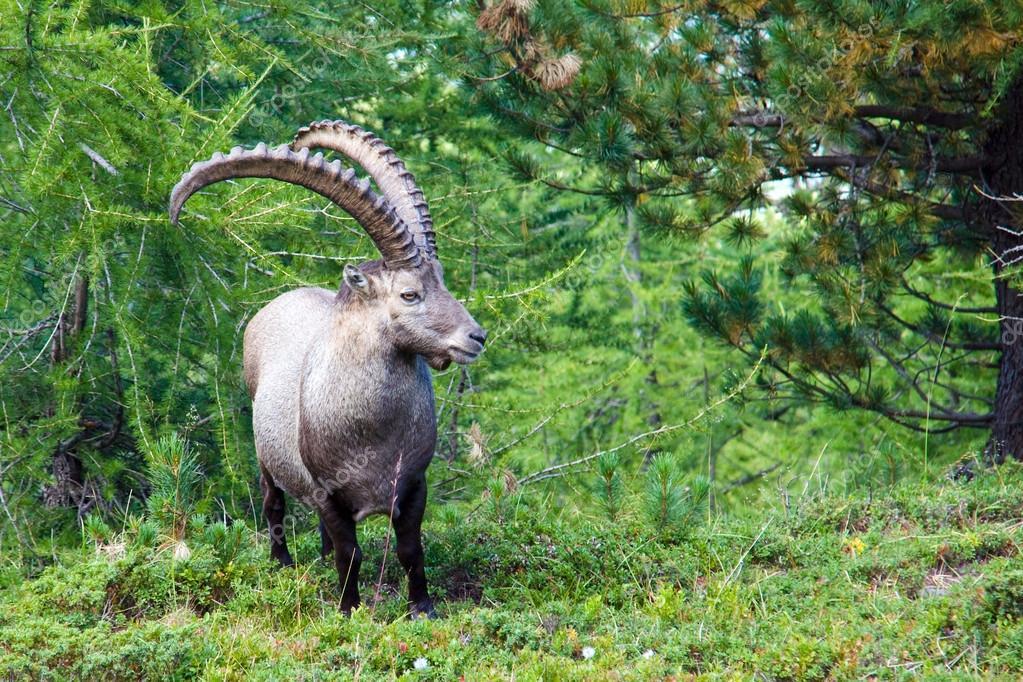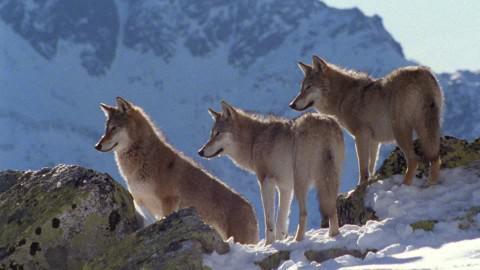The first image is the image on the left, the second image is the image on the right. Given the left and right images, does the statement "the sky is visible in the image on the right" hold true? Answer yes or no. Yes. The first image is the image on the left, the second image is the image on the right. For the images shown, is this caption "There are at least two goats and none of them are on the grass." true? Answer yes or no. No. 